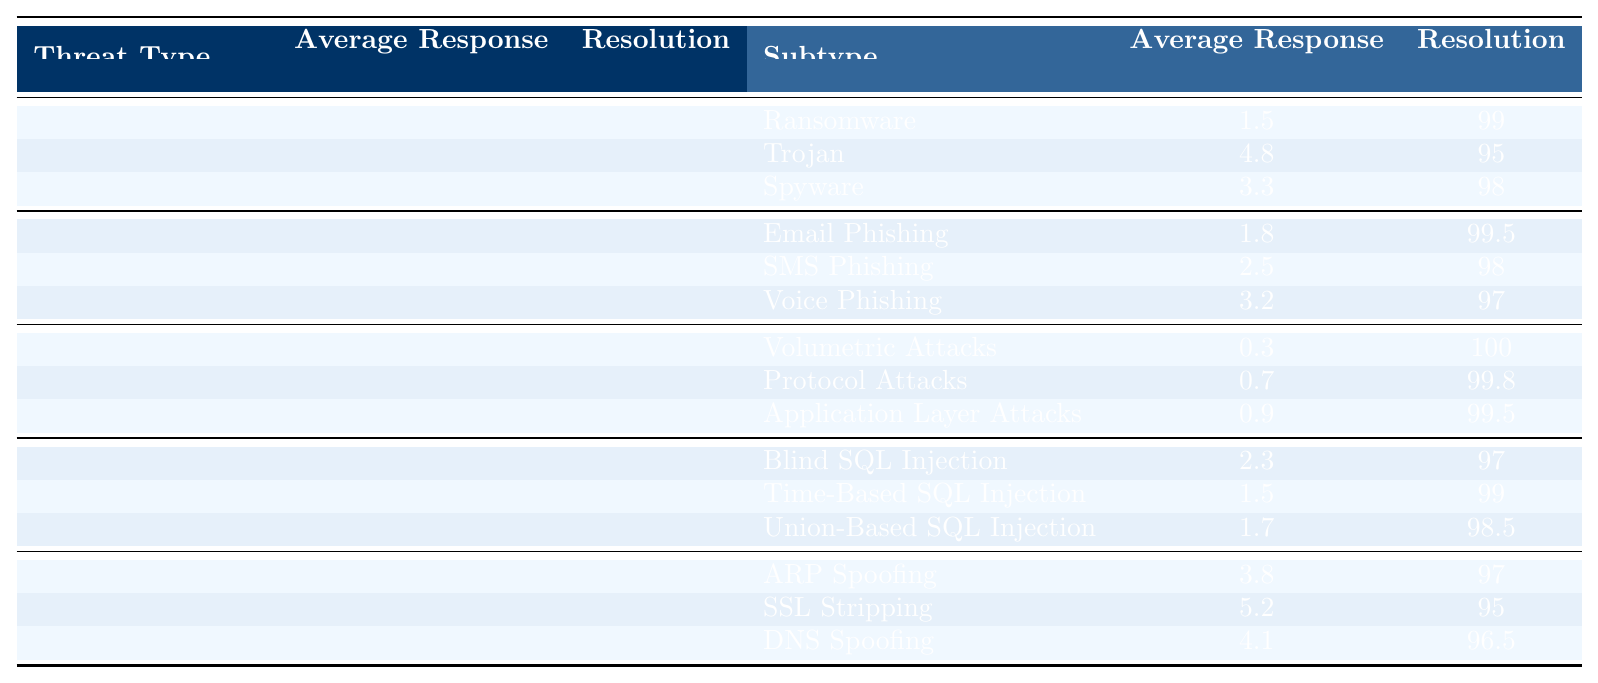What is the average response time for Malware? The table shows that the average response time for Malware is listed as 3.2 hours.
Answer: 3.2 hours What is the resolution rate for DDoS attacks? According to the table, the resolution rate for DDoS attacks is 100%.
Answer: 100% Which subtype of Phishing has the highest resolution rate? The table indicates that Email Phishing has the highest resolution rate at 99.5%.
Answer: Email Phishing What is the difference in average response time between Ransomware and Trojan subtypes? The response time for Ransomware is 1.5 hours, and for Trojan, it is 4.8 hours. The difference is 4.8 - 1.5 = 3.3 hours.
Answer: 3.3 hours What is the average response time for all subtypes of SQL Injection? The average response time can be calculated by adding the response times for all three subtypes: 2.3 (Blind) + 1.5 (Time-Based) + 1.7 (Union-Based) = 5.5 hours. Then, divide by 3 (the number of subtypes): 5.5 / 3 = 1.83 hours.
Answer: 1.83 hours True or False: The average resolution rate for Man-in-the-Middle threats is below 97%. The table shows the resolution rate for Man-in-the-Middle threats is 96%, which is indeed below 97%.
Answer: True What type of attack has the shortest average response time? The DDoS attack has an average response time of 0.5 hours, which is shorter than any other threat type listed in the table.
Answer: DDoS Which threat type contains the highest average response time and what is that time? Man-in-the-Middle has the highest average response time of 4.5 hours as per the table.
Answer: 4.5 hours How does the average response time for Application Layer Attacks compare to that for Protocol Attacks? Application Layer Attacks have an average response time of 0.9 hours, while Protocol Attacks have 0.7 hours. Therefore, Application Layer Attacks take 0.2 hours longer.
Answer: 0.2 hours longer What is the overall resolution rate for all types of Malware? The table indicates that the average resolution rate across all subtypes of Malware is the average of 99 (Ransomware), 95 (Trojan), and 98 (Spyware), which is (99 + 95 + 98) / 3 = 97.33%.
Answer: 97.33% 